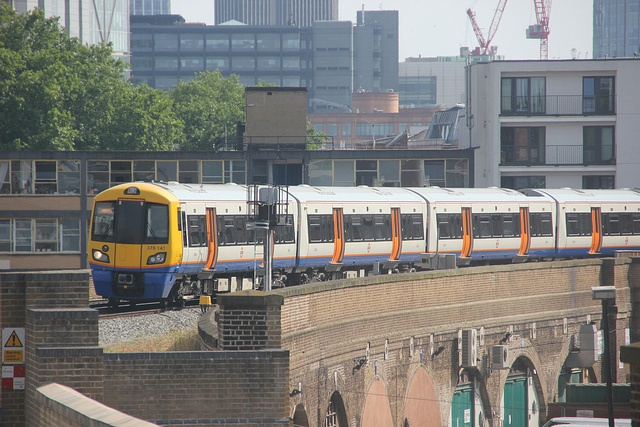Describe the objects in this image and their specific colors. I can see a train in gray, lightgray, darkgray, and black tones in this image. 